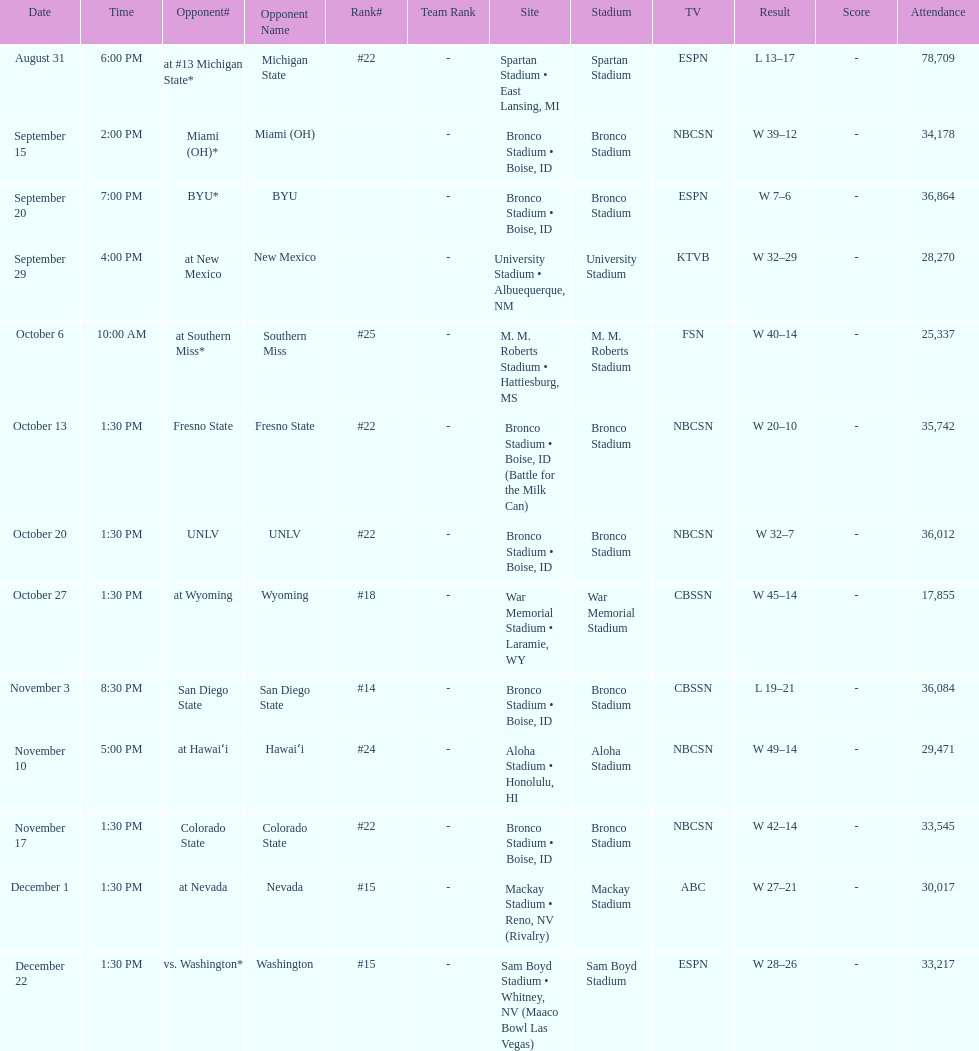What was there top ranked position of the season? #14. 